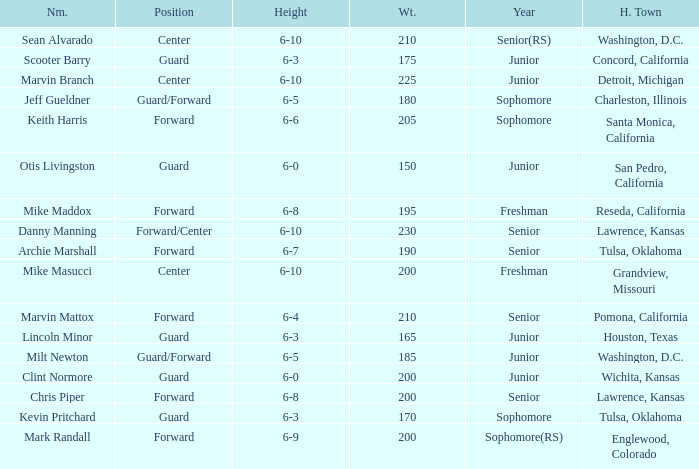Can you tell me the average Weight that has Height of 6-9? 200.0. 